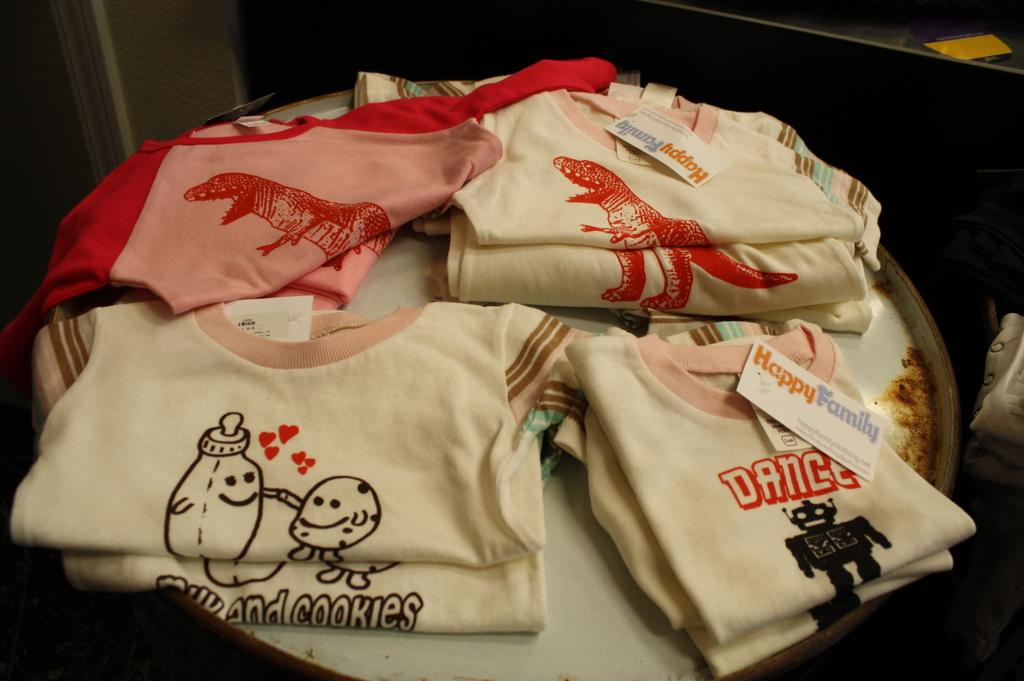What can be seen in the image? There are folded clothes in the image. Can you describe the background of the image? The background of the image is slightly dark. What type of dinner is being prepared in the image? There is no dinner or any cooking activity present in the image; it only shows folded clothes. What kind of butter is visible in the image? There is no butter present in the image. 